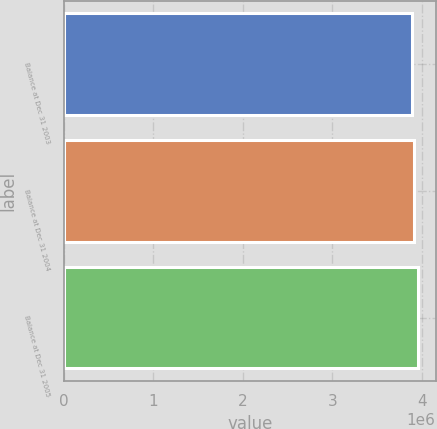<chart> <loc_0><loc_0><loc_500><loc_500><bar_chart><fcel>Balance at Dec 31 2003<fcel>Balance at Dec 31 2004<fcel>Balance at Dec 31 2005<nl><fcel>3.8905e+06<fcel>3.91106e+06<fcel>3.95671e+06<nl></chart> 